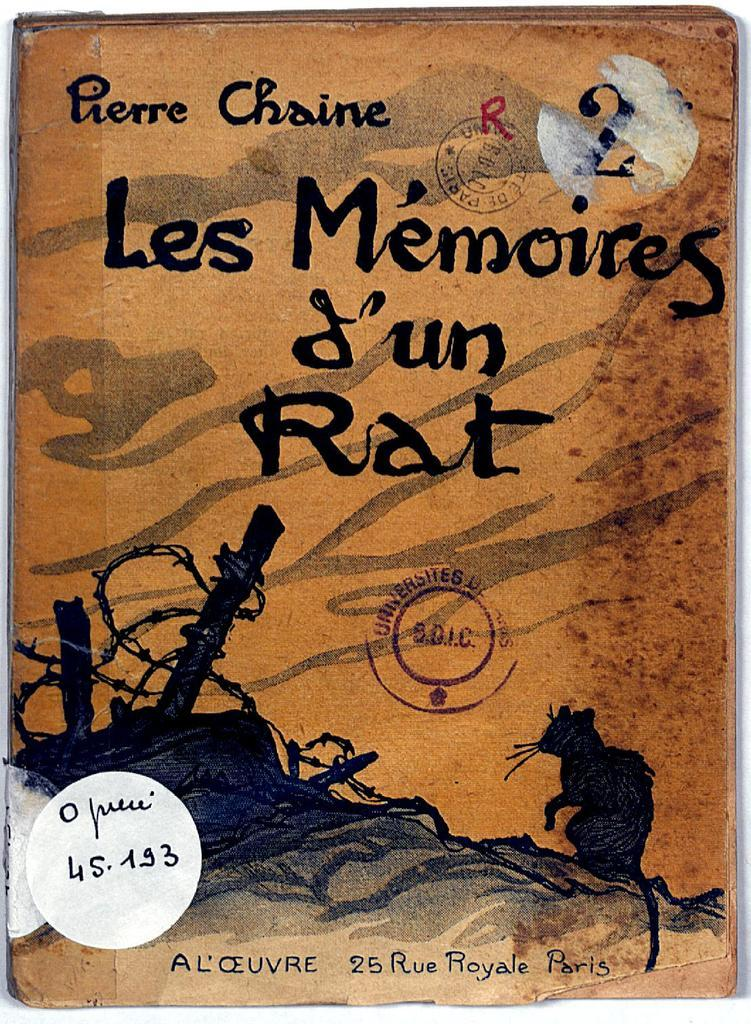Provide a one-sentence caption for the provided image. orange and black book, les m'emories j'un rat by pierre chaine. 